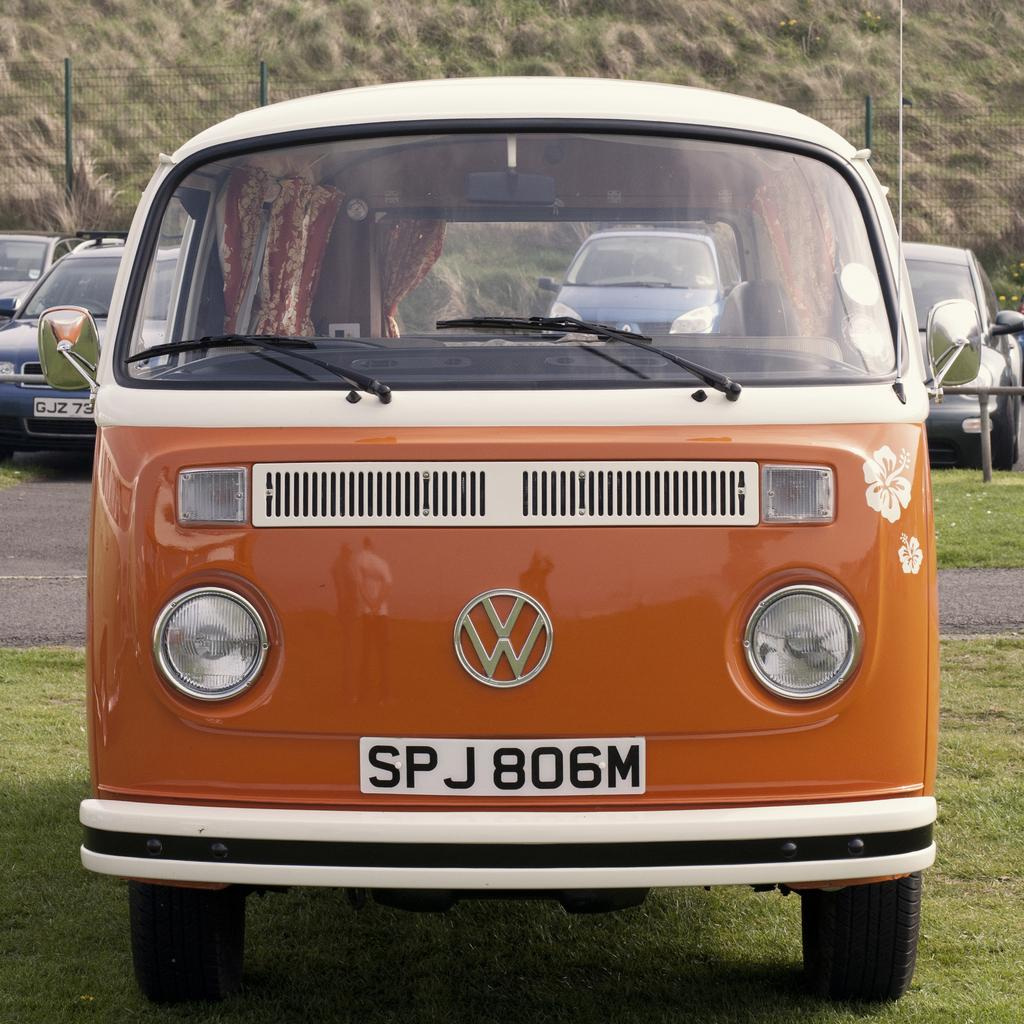<image>
Offer a succinct explanation of the picture presented. An orange Volkswagen mini bus with number plate: SPJ806M. 